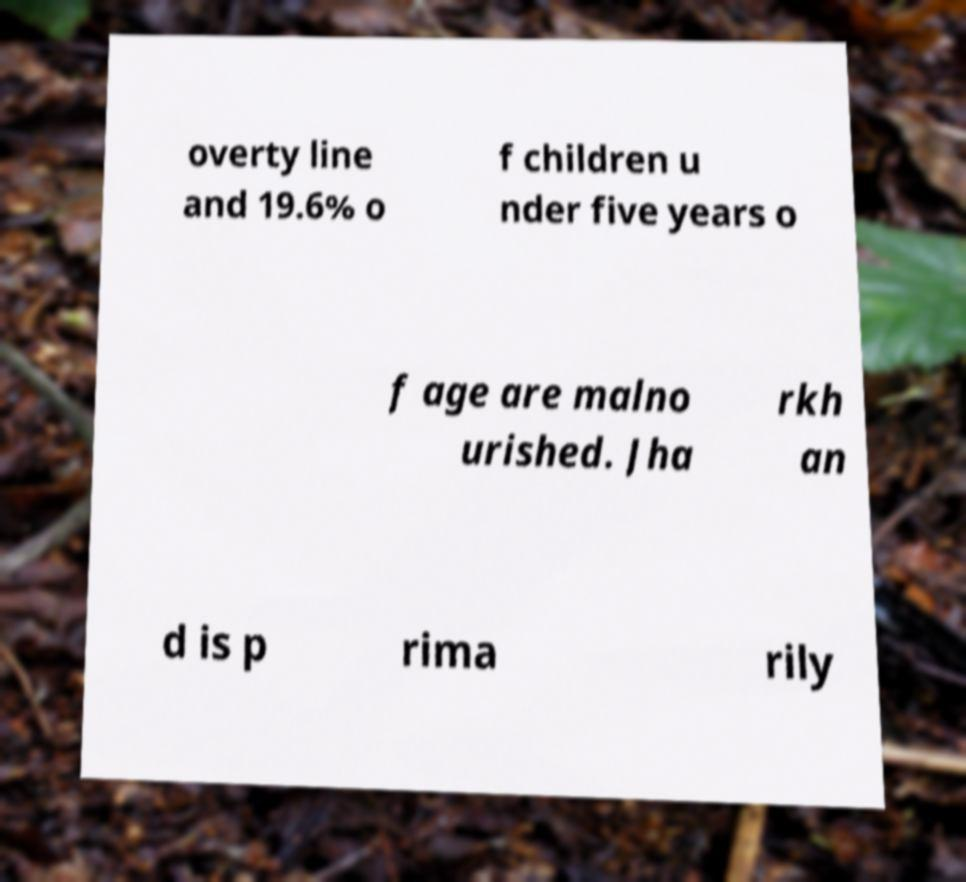Could you extract and type out the text from this image? overty line and 19.6% o f children u nder five years o f age are malno urished. Jha rkh an d is p rima rily 